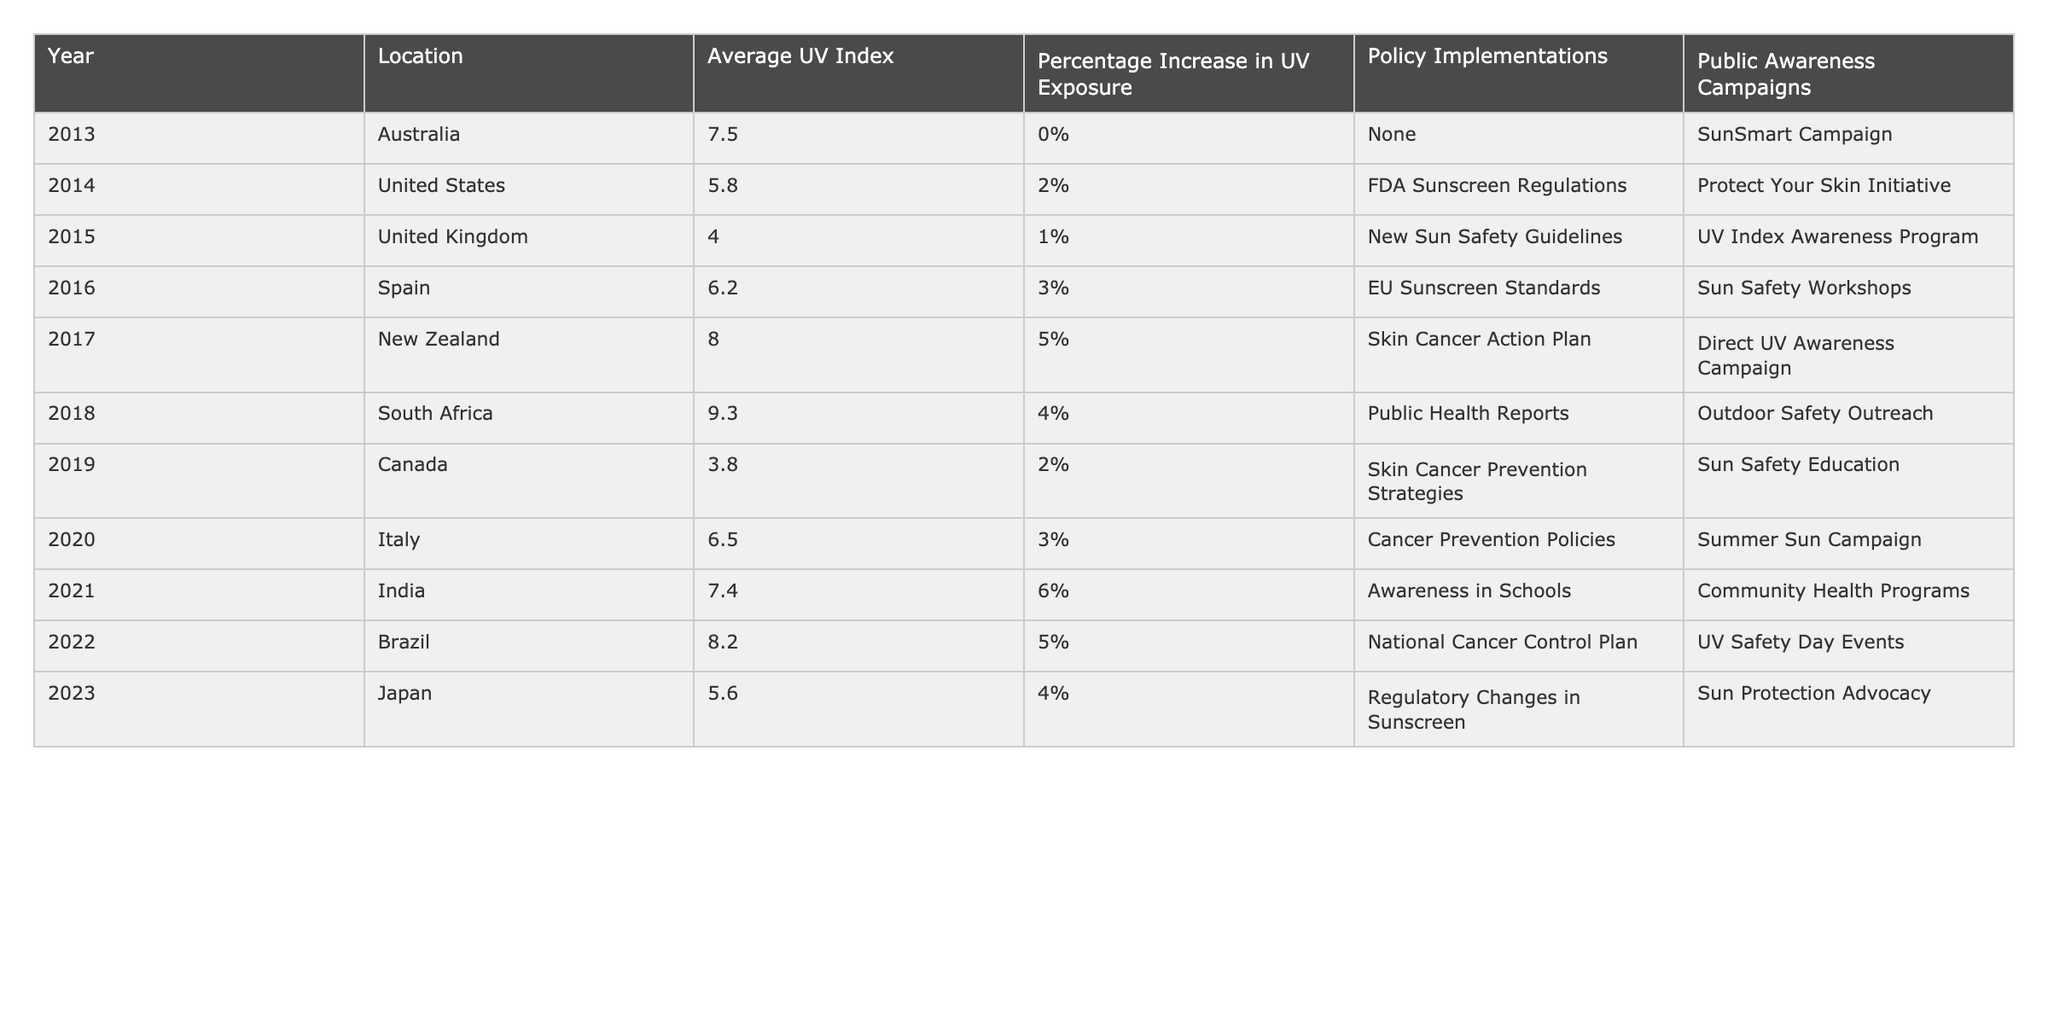What was the average UV Index for Australia in 2013? The table shows that the Average UV Index for Australia in 2013 was 7.5.
Answer: 7.5 Which location had the highest percentage increase in UV exposure in 2021? The table reveals that India had the highest percentage increase in UV exposure in 2021 with 6%.
Answer: 6% What is the average UV Index across all the listed countries in 2019 and 2020? The Average UV Index for Canada in 2019 is 3.8 and for Italy in 2020 is 6.5. The average is (3.8 + 6.5) / 2 = 5.15.
Answer: 5.15 Did the implementation of policies correlate with higher UV Index readings across the years? The data indicates various policy implementations, but to assess correlation, we need to analyze trends across multiple years with respect to UV Index values and their subsequent changes. For instance, the UV Index increased from 5.8 to 6.5 alongside different policy implementations between the years observed.
Answer: No definitive conclusion Which year saw the largest drop in UV exposure from the previous year based on percentage increase? By comparing the percentage increases, the largest drop occurred from 2018 (4% increase) to 2019 (2% increase), indicating a 2% decrease in the increase.
Answer: 2% In which year did the SunSmart Campaign take place, and what was the Average UV Index for that year? The SunSmart Campaign was implemented in Australia in 2013, during which the Average UV Index was 7.5 from the table.
Answer: 7.5 in 2013 Was there any year when the Average UV Index was below 5? The table shows that the United Kingdom in 2015 had an Average UV Index of 4.0, which is below 5.
Answer: Yes What trend can be observed from the Average UV Index from 2013 to 2023? Analyzing the data from 2013 (7.5) to 2023 (5.6), we see fluctuations in UV Index, but generally, the UV Index shows a gradual increase until 2018 followed by a slight decline in 2023.
Answer: Fluctuating trend with a gradual increase, ending lower in 2023 